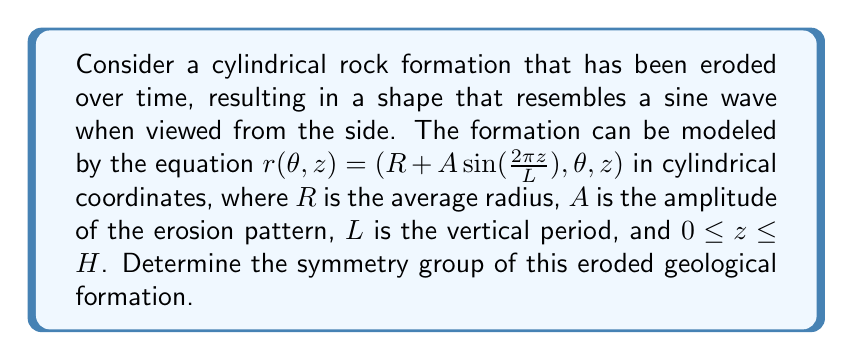Can you solve this math problem? To determine the symmetry group of this eroded geological formation, we need to analyze its invariances under various transformations:

1. Rotational symmetry:
   The formation is symmetric under rotations around the z-axis by any angle. This is because the radius is independent of θ in the equation.

2. Vertical translation symmetry:
   The sine function in the equation repeats every $L$ units in the z-direction. Therefore, the formation has translational symmetry of period $L$ along the z-axis.

3. Reflection symmetry:
   a) The formation is symmetric under reflection across any plane containing the z-axis (vertical planes).
   b) It is also symmetric under reflection across horizontal planes at $z = \frac{nL}{2}$, where $n$ is an integer, due to the properties of the sine function.

4. Screw symmetry:
   The formation exhibits helical symmetry, combining rotation around the z-axis with translation along it.

The symmetry group of this formation is thus a combination of:
- $SO(2)$ for continuous rotations around the z-axis
- $\mathbb{Z}$ for discrete translations along the z-axis
- $\mathbb{Z}_2 \times \mathbb{Z}_2$ for reflections across vertical and horizontal planes

The full symmetry group can be described as:
$$(SO(2) \rtimes \mathbb{Z}) \times (\mathbb{Z}_2 \times \mathbb{Z}_2)$$

Where $\rtimes$ denotes the semidirect product, accounting for the screw symmetry (helical symmetry) of the formation.
Answer: $(SO(2) \rtimes \mathbb{Z}) \times (\mathbb{Z}_2 \times \mathbb{Z}_2)$ 